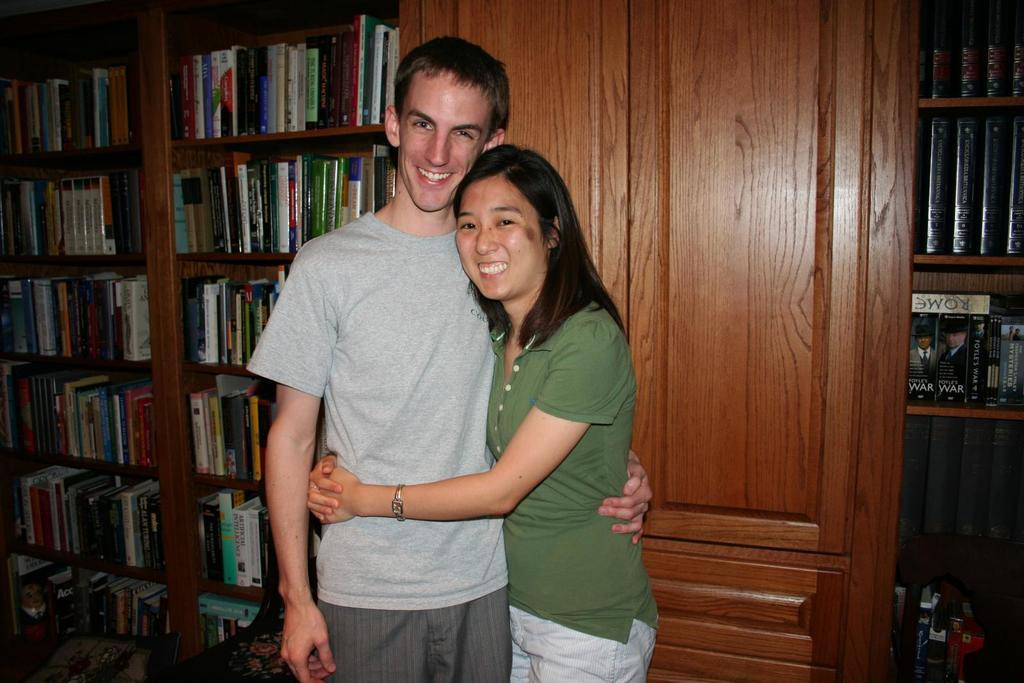Who are the two people in the image? There is a man and a woman in the image. What are the man and woman doing in the image? The man and woman are standing and holding each other. What can be seen in the background of the image? There is a group of books placed in shelves in the image. What architectural feature is present in the image? There is a door in the image. What type of cup is the creator holding in the image? There is no creator or cup present in the image. What rule is being enforced by the man and woman in the image? There is no rule being enforced in the image; the man and woman are simply standing and holding each other. 